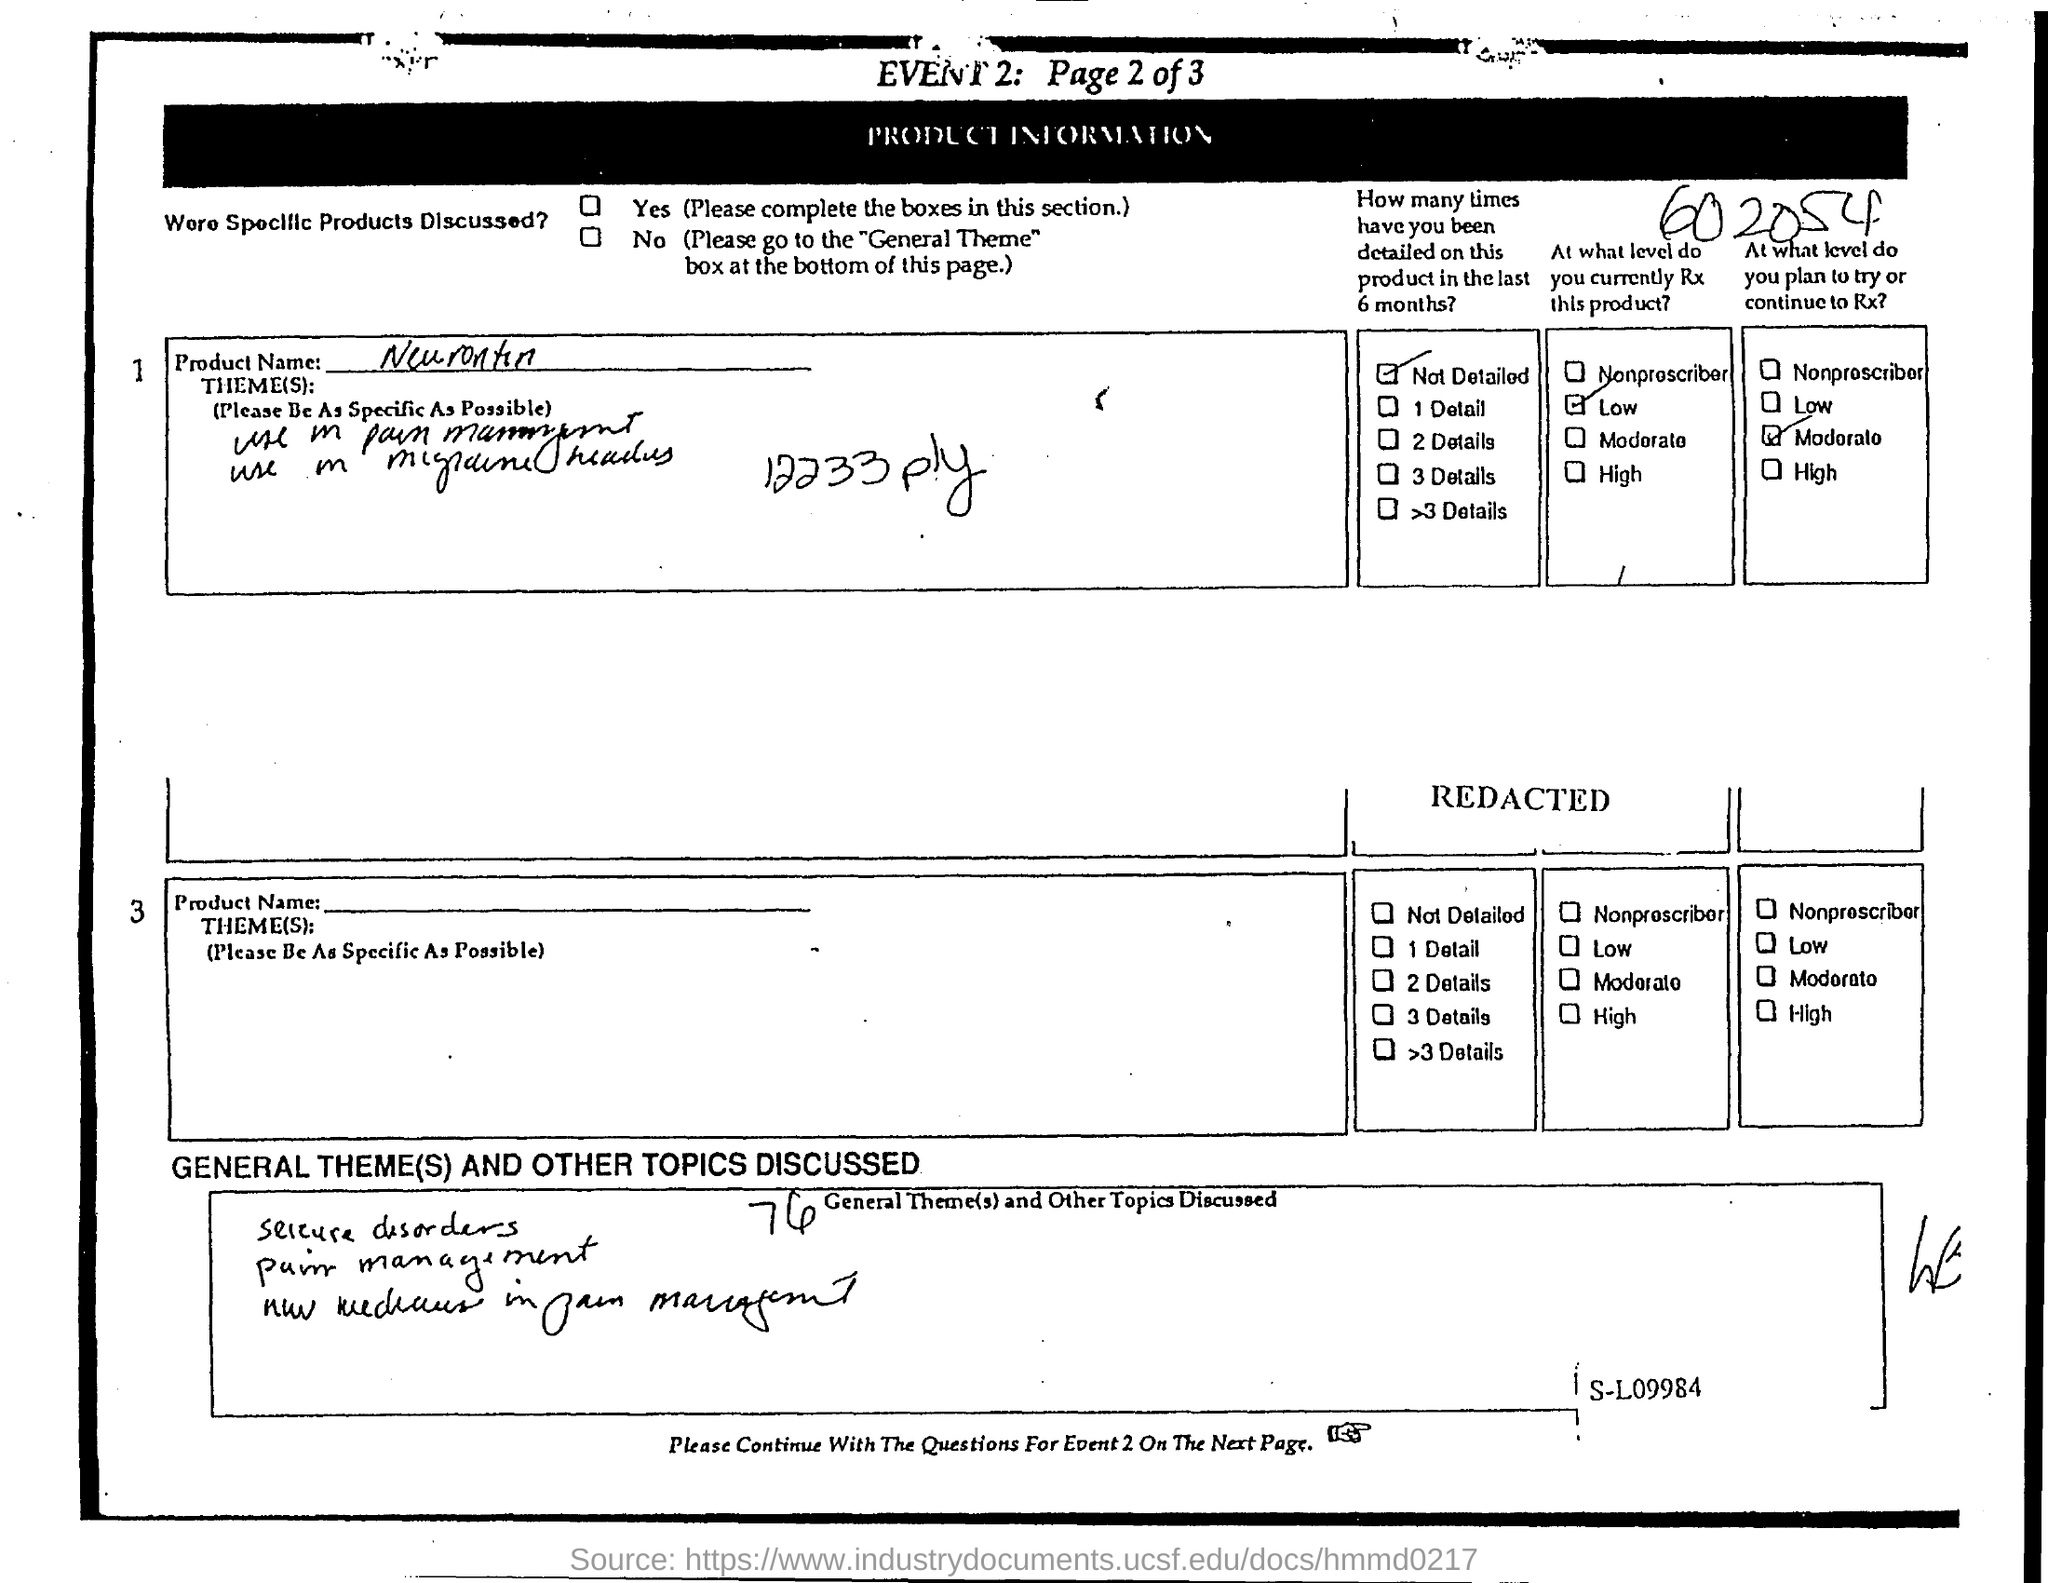Outline some significant characteristics in this image. The title of the document is [insert title]. The product name is Neurontin. 